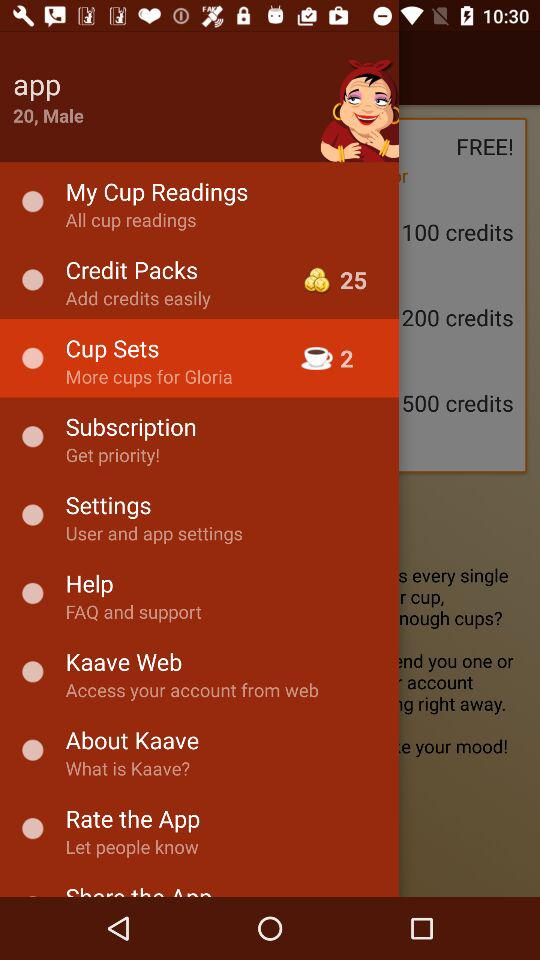What is the age given on the screen? The given age is 20. 